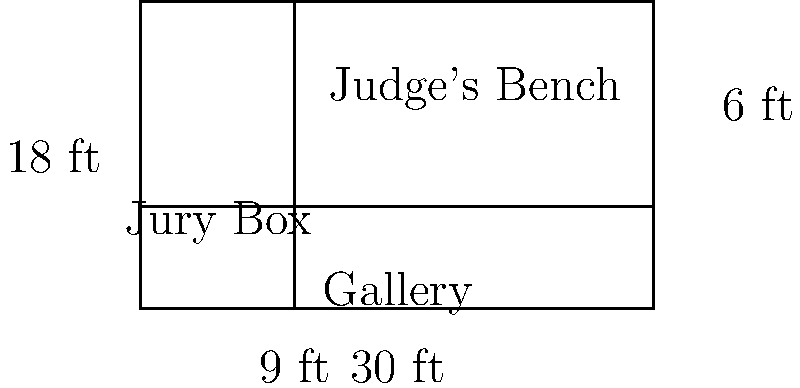In a courtroom layout, the main floor area is rectangular and measures 30 ft in length and 18 ft in width. The jury box occupies a 9 ft wide strip along one side, while the judge's bench is positioned 6 ft from the opposite wall. Calculate the remaining floor area (in square feet) available for the gallery and other courtroom activities. To calculate the remaining floor area for the gallery and other courtroom activities, we need to follow these steps:

1. Calculate the total area of the courtroom:
   $A_{total} = 30 \text{ ft} \times 18 \text{ ft} = 540 \text{ sq ft}$

2. Calculate the area occupied by the jury box:
   $A_{jury} = 9 \text{ ft} \times 18 \text{ ft} = 162 \text{ sq ft}$

3. Calculate the area in front of the judge's bench:
   $A_{judge} = 6 \text{ ft} \times 30 \text{ ft} = 180 \text{ sq ft}$

4. Calculate the remaining area by subtracting the jury box and judge's bench areas from the total area:
   $$A_{remaining} = A_{total} - (A_{jury} + A_{judge})$$
   $$A_{remaining} = 540 \text{ sq ft} - (162 \text{ sq ft} + 180 \text{ sq ft})$$
   $$A_{remaining} = 540 \text{ sq ft} - 342 \text{ sq ft} = 198 \text{ sq ft}$$

Therefore, the remaining floor area available for the gallery and other courtroom activities is 198 square feet.
Answer: 198 sq ft 